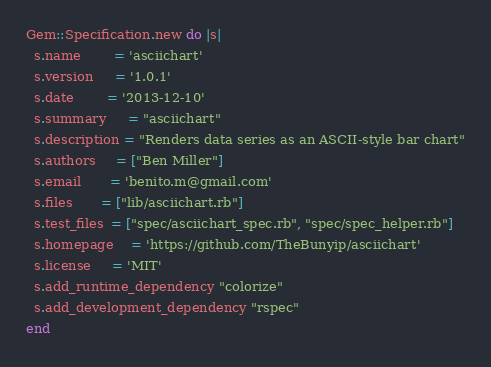<code> <loc_0><loc_0><loc_500><loc_500><_Ruby_>Gem::Specification.new do |s|
  s.name        = 'asciichart'
  s.version     = '1.0.1'
  s.date        = '2013-12-10'
  s.summary     = "asciichart"
  s.description = "Renders data series as an ASCII-style bar chart"
  s.authors     = ["Ben Miller"]
  s.email       = 'benito.m@gmail.com'
  s.files       = ["lib/asciichart.rb"]
  s.test_files  = ["spec/asciichart_spec.rb", "spec/spec_helper.rb"]
  s.homepage    = 'https://github.com/TheBunyip/asciichart'
  s.license     = 'MIT'
  s.add_runtime_dependency "colorize"
  s.add_development_dependency "rspec"
end</code> 